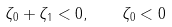<formula> <loc_0><loc_0><loc_500><loc_500>\zeta _ { 0 } + \zeta _ { 1 } < 0 , \quad \zeta _ { 0 } < 0</formula> 